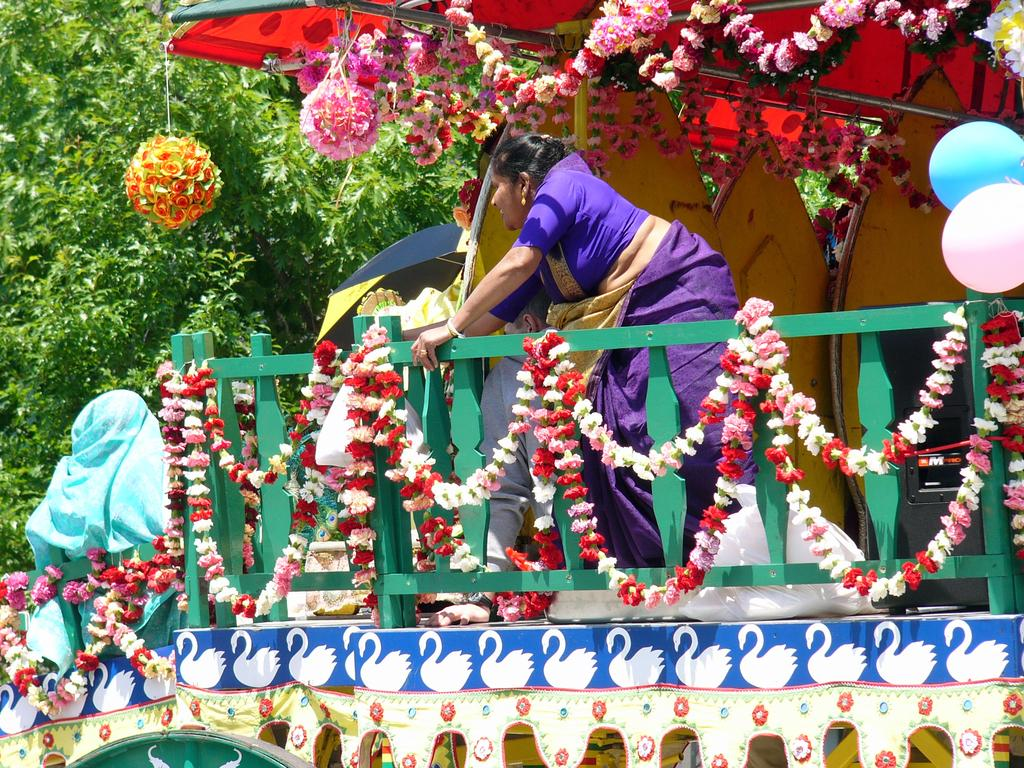What is the main subject in the image? There is a vehicle in the image. What is the woman doing in the image? A woman is standing on the vehicle. What decorative items can be seen in the image? There are balloons and flowers in the image. What type of natural elements are visible in the image? There are trees visible in the top left side of the image. What type of cream is being used to measure the angle of the vehicle in the image? There is no cream or measurement of angles present in the image. The woman is simply standing on the vehicle, and there are no references to cream or angles. 